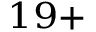<formula> <loc_0><loc_0><loc_500><loc_500>^ { 1 9 + }</formula> 